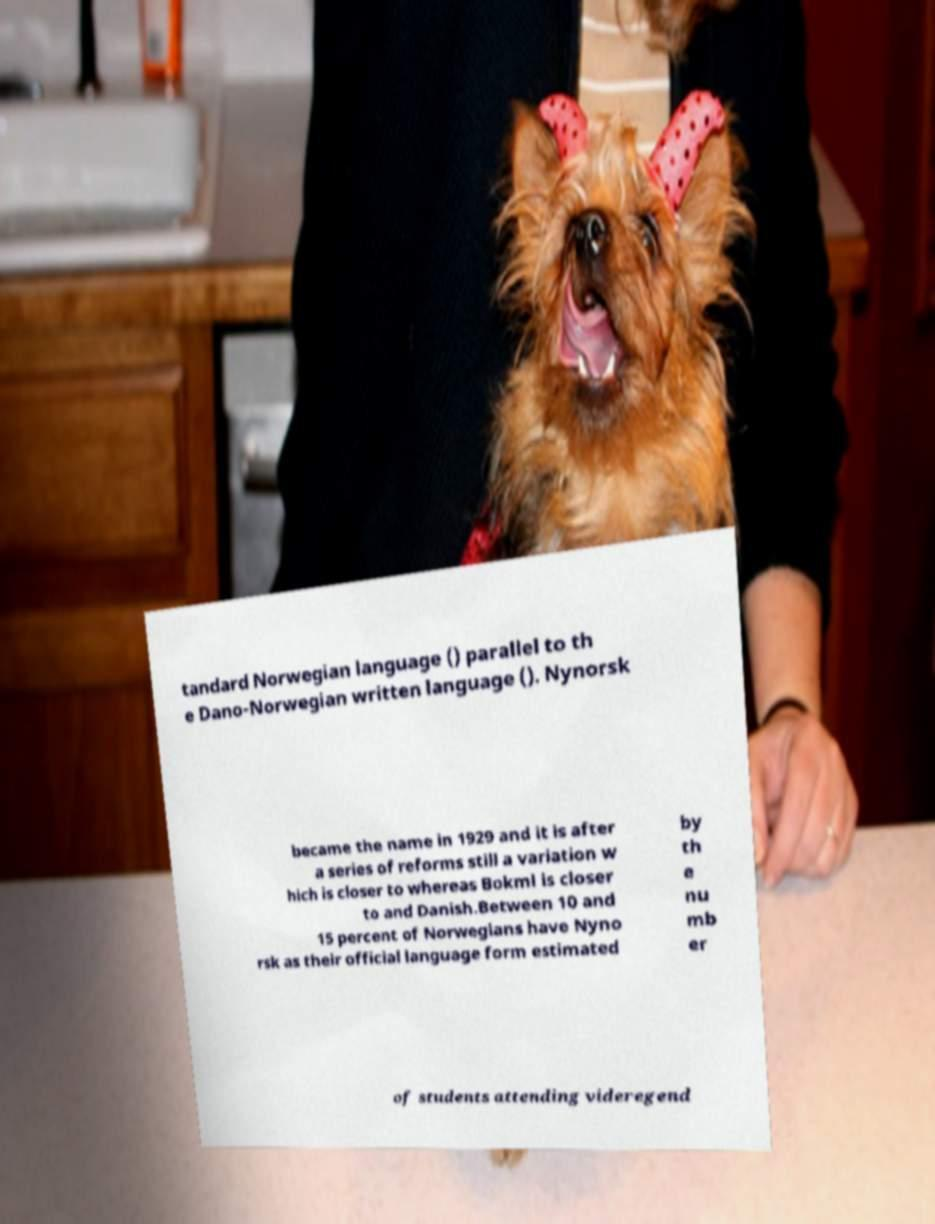Could you assist in decoding the text presented in this image and type it out clearly? tandard Norwegian language () parallel to th e Dano-Norwegian written language (). Nynorsk became the name in 1929 and it is after a series of reforms still a variation w hich is closer to whereas Bokml is closer to and Danish.Between 10 and 15 percent of Norwegians have Nyno rsk as their official language form estimated by th e nu mb er of students attending videregend 